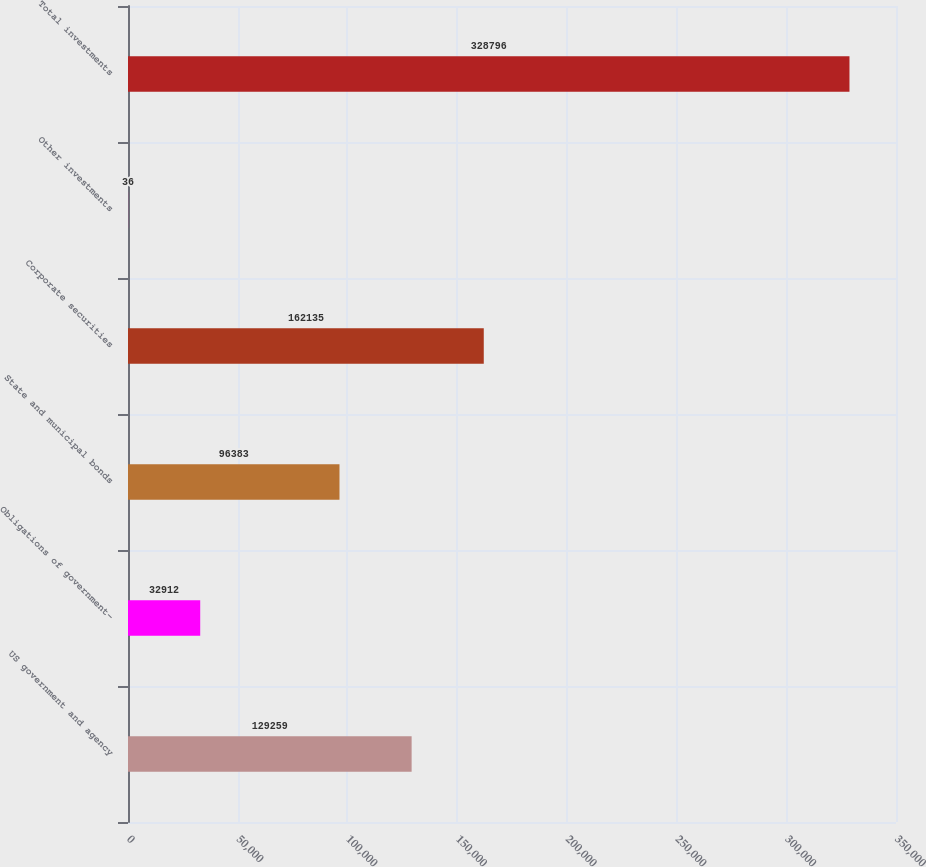Convert chart. <chart><loc_0><loc_0><loc_500><loc_500><bar_chart><fcel>US government and agency<fcel>Obligations of government-<fcel>State and municipal bonds<fcel>Corporate securities<fcel>Other investments<fcel>Total investments<nl><fcel>129259<fcel>32912<fcel>96383<fcel>162135<fcel>36<fcel>328796<nl></chart> 